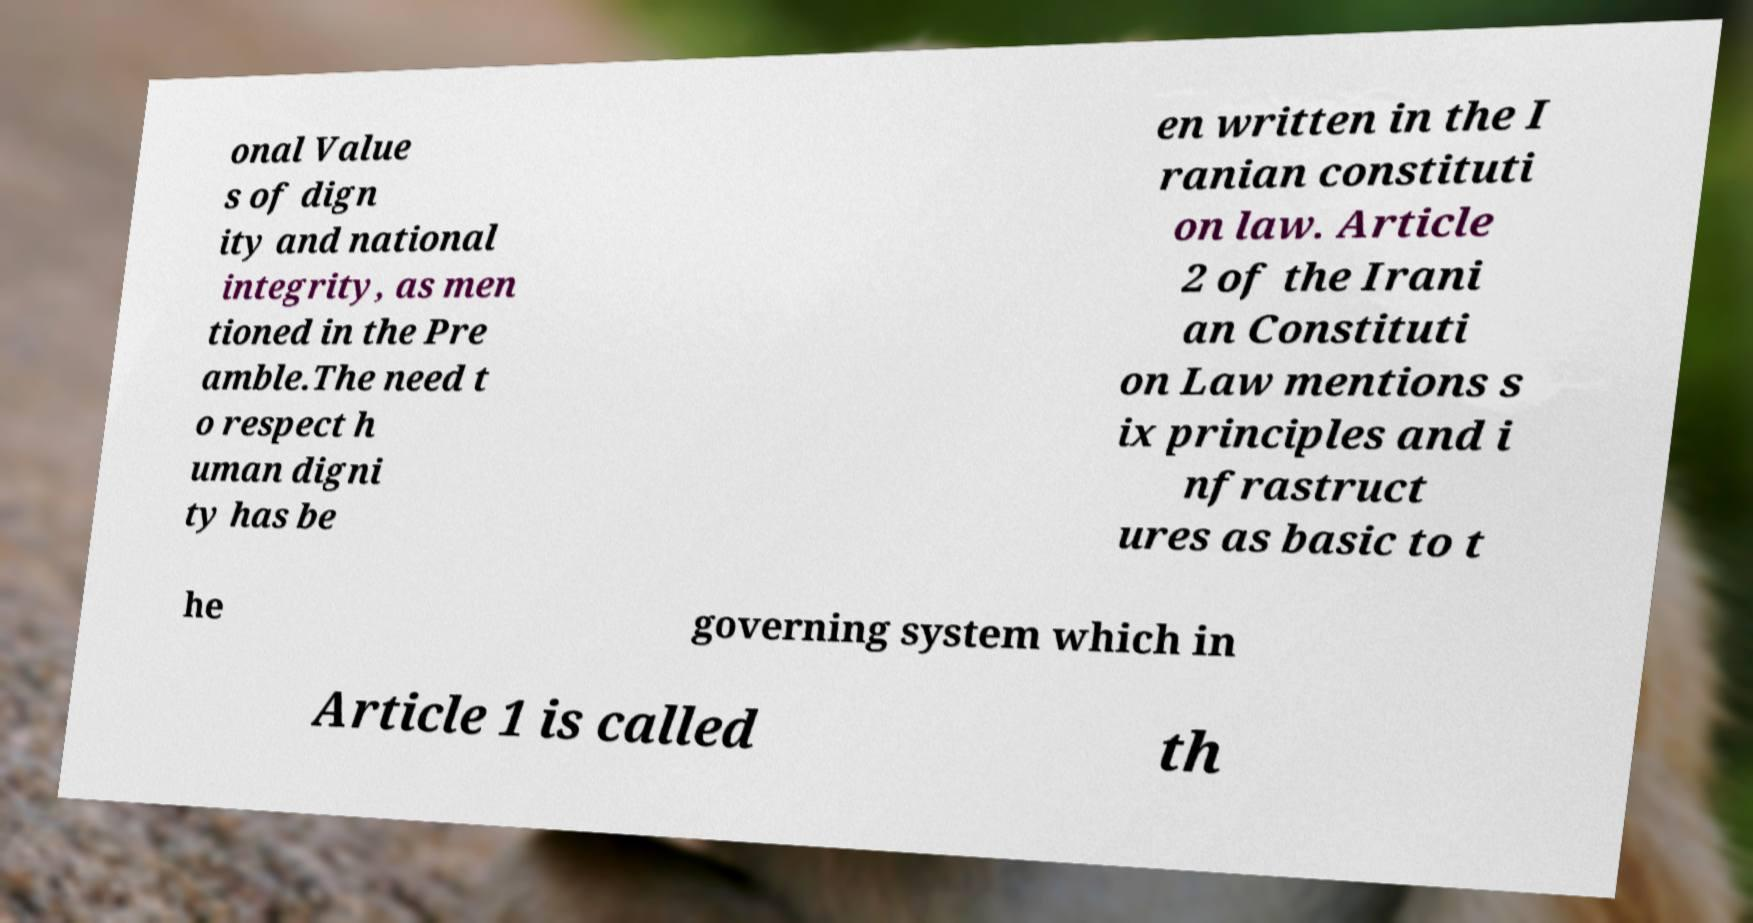Could you extract and type out the text from this image? onal Value s of dign ity and national integrity, as men tioned in the Pre amble.The need t o respect h uman digni ty has be en written in the I ranian constituti on law. Article 2 of the Irani an Constituti on Law mentions s ix principles and i nfrastruct ures as basic to t he governing system which in Article 1 is called th 